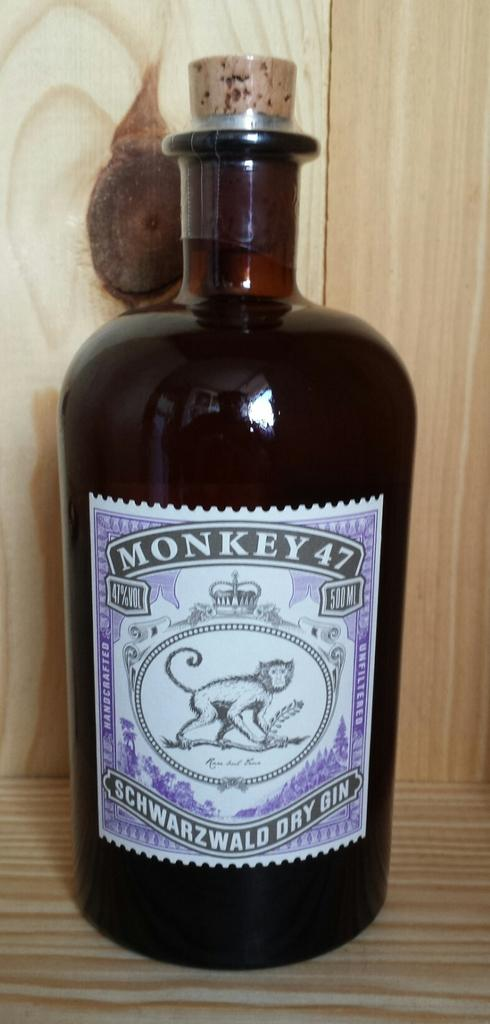What is the main object in the image? There is a bottle of gin in the image. Where is the bottle of gin located? The bottle of gin is on a table. What type of club is being used to hit the bottle of gin in the image? There is no club present in the image, and the bottle of gin is not being hit. 